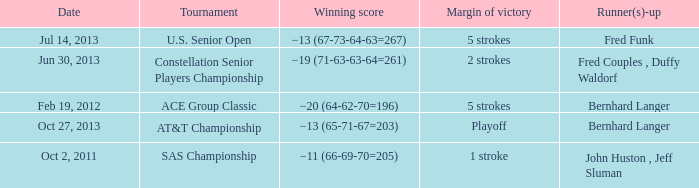Who's the Runner(s)-up with a Winning score of −19 (71-63-63-64=261)? Fred Couples , Duffy Waldorf. 